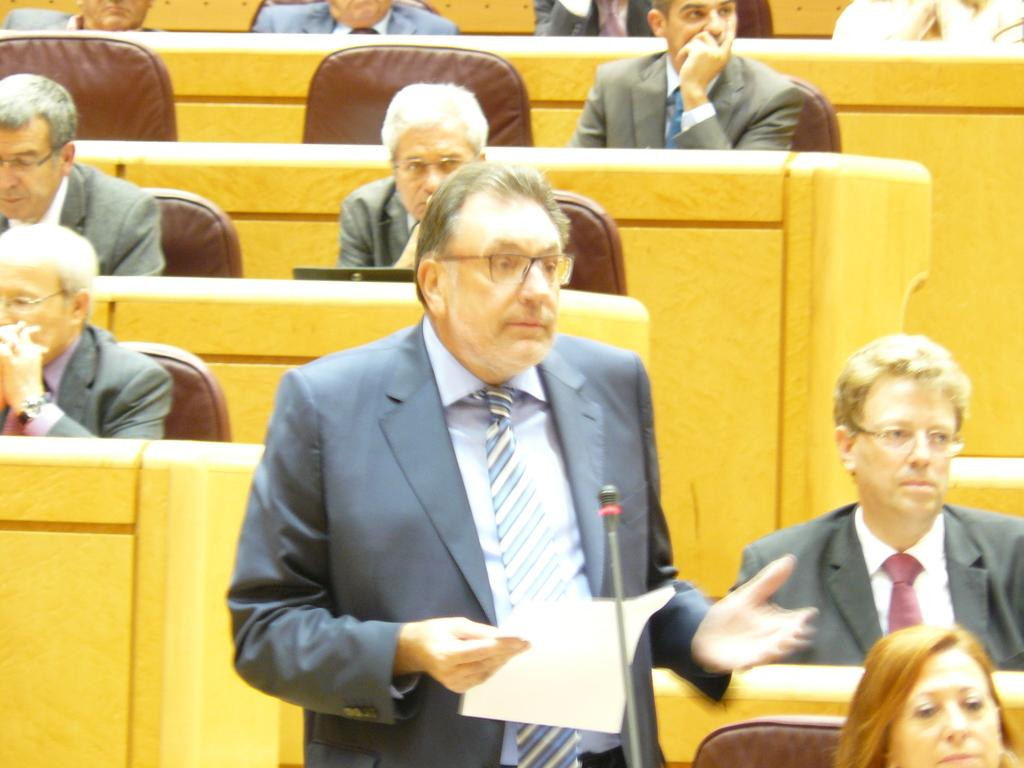Who is present in the image? There are people in the image. What are the people doing in the image? The people are sitting on chairs. What object is visible in the image that is typically used for amplifying sound? There is a microphone in the image. What is the man holding in the image? The man is holding a paper. What type of toothbrush is the man using in the image? There is no toothbrush present in the image; the man is holding a paper. What part of the room is the microphone located in the image? The provided facts do not specify the location of the microphone in the room, only that it is present in the image. 